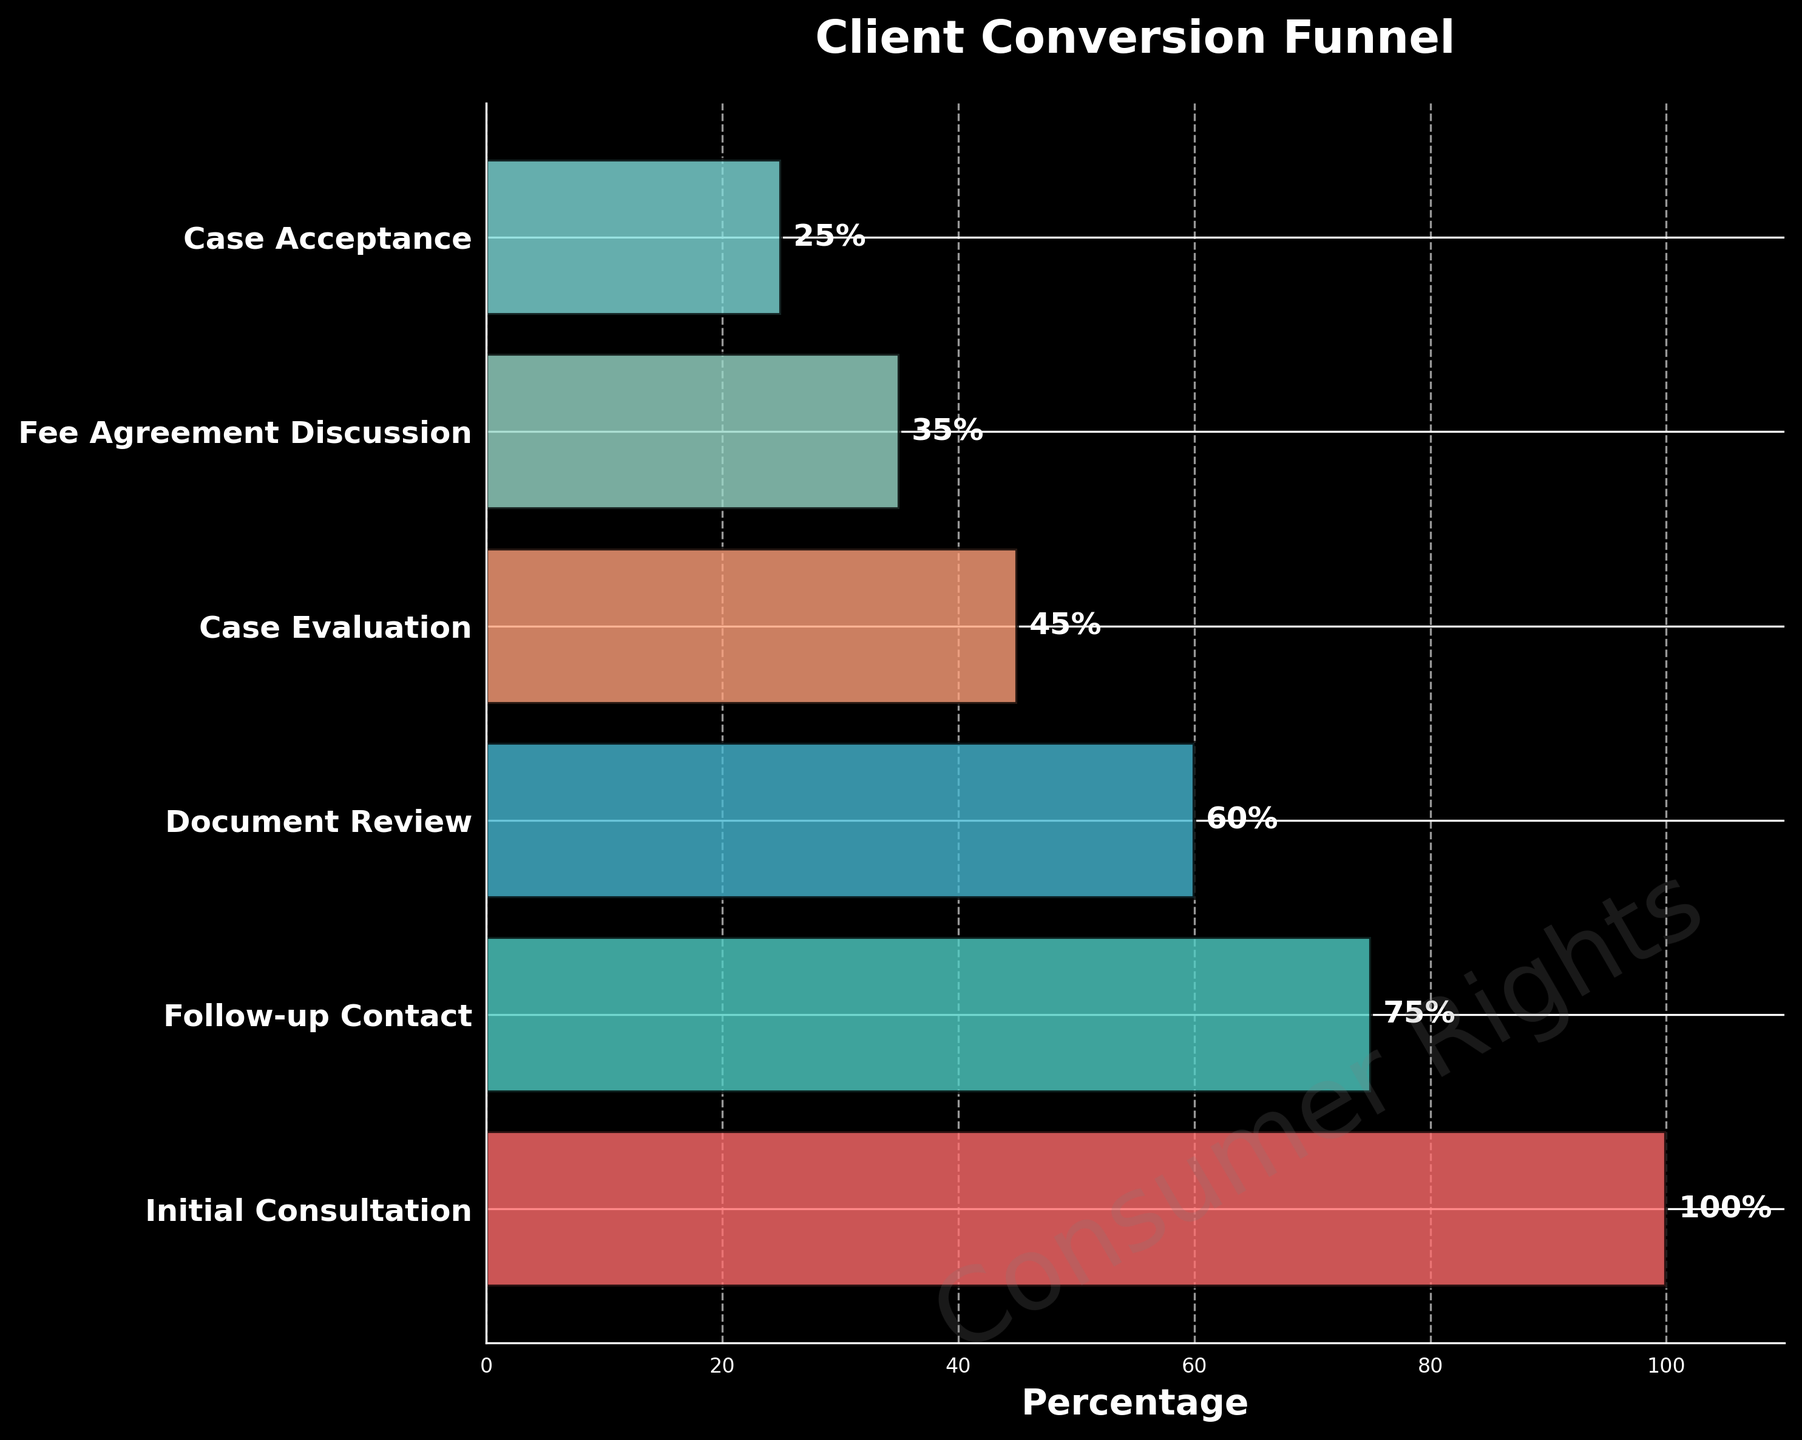What's the title of the figure? The title of the figure is usually placed at the top center of the plot. Based on the provided code, the title "Client Conversion Funnel" is clearly stated there.
Answer: Client Conversion Funnel What stage has the highest conversion rate? The highest conversion rate corresponds to the initial stage of the funnel. In funnel charts, the first stage typically starts at 100%, as it includes all initial participants or subjects.
Answer: Initial Consultation How many stages are there in this funnel chart? By counting the different stages listed along the y-axis (from "Initial Consultation" to "Case Acceptance"), we can determine the number of stages.
Answer: 6 Which stage has the biggest drop in conversion rate from the previous stage? To determine the biggest drop, look at the difference between consecutive stages. The difference between "Initial Consultation" (100%) and "Follow-up Contact" (75%) is 25%, which is larger than any other drop between stages.
Answer: Initial Consultation to Follow-up Contact What is the conversion rate at the Case Acceptance stage? By looking at the percentage value next to "Case Acceptance" on the y-axis, you can identify the conversion rate.
Answer: 25% What is the total percentage drop from Initial Consultation to Case Acceptance? Subtract the conversion rate at the final stage from the conversion rate at the first stage. 100% (Initial Consultation) - 25% (Case Acceptance) = 75%.
Answer: 75% Which two consecutive stages have equal spacing in terms of conversion rate drop? By examining the percentage differences, the drop from "Follow-up Contact" (75%) to "Document Review" (60%) and from "Case Evaluation" (45%) to "Fee Agreement Discussion" (35%) are both 15%.
Answer: Follow-up Contact to Document Review and Case Evaluation to Fee Agreement Discussion What is the average conversion rate of all stages excluding Initial Consultation? Add the conversion rates for the five stages excluding "Initial Consultation" and divide by the number of stages: (75 + 60 + 45 + 35 + 25) / 5 = 240 / 5 = 48.
Answer: 48% Between which stages do we see the steepest decline in conversion rates? The steepest decline is measured by the largest drop between two consecutive stages. The decline between "Initial Consultation" and "Follow-up Contact" (25%) is the steepest.
Answer: Initial Consultation to Follow-up Contact Is the conversion rate consistently decreasing through all stages? By examining the trend from the figure, each subsequent stage in the funnel shows a lower conversion rate than the previous one, indicating a consistent decrease.
Answer: Yes 